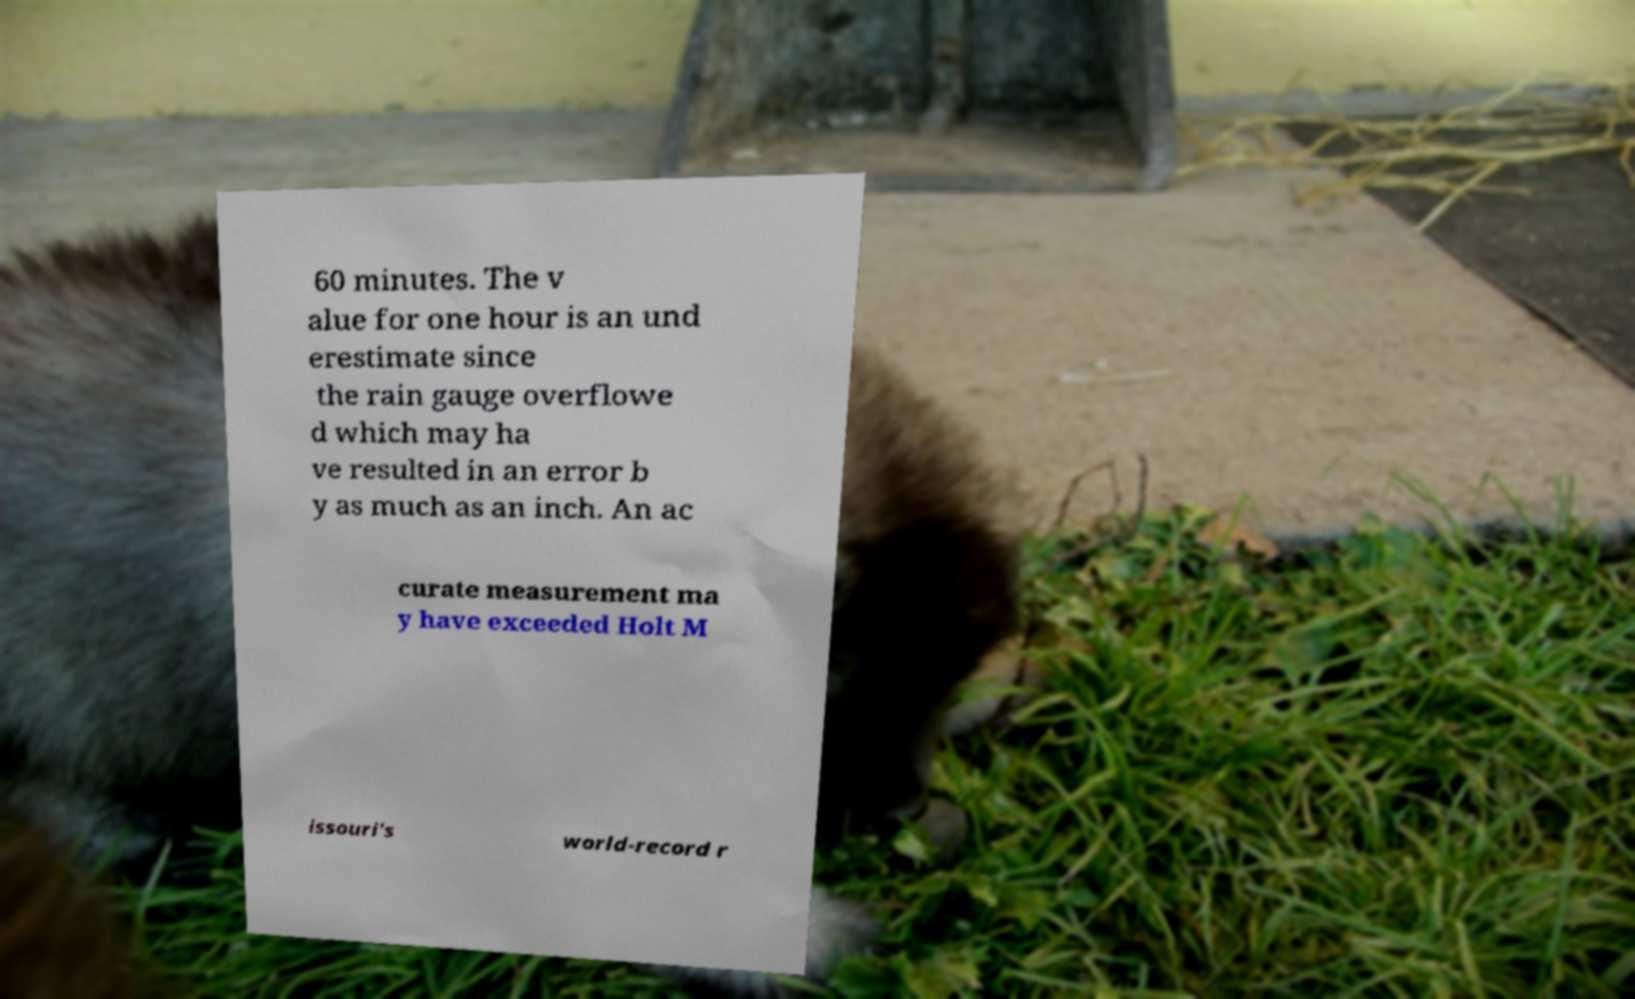Could you assist in decoding the text presented in this image and type it out clearly? 60 minutes. The v alue for one hour is an und erestimate since the rain gauge overflowe d which may ha ve resulted in an error b y as much as an inch. An ac curate measurement ma y have exceeded Holt M issouri's world-record r 